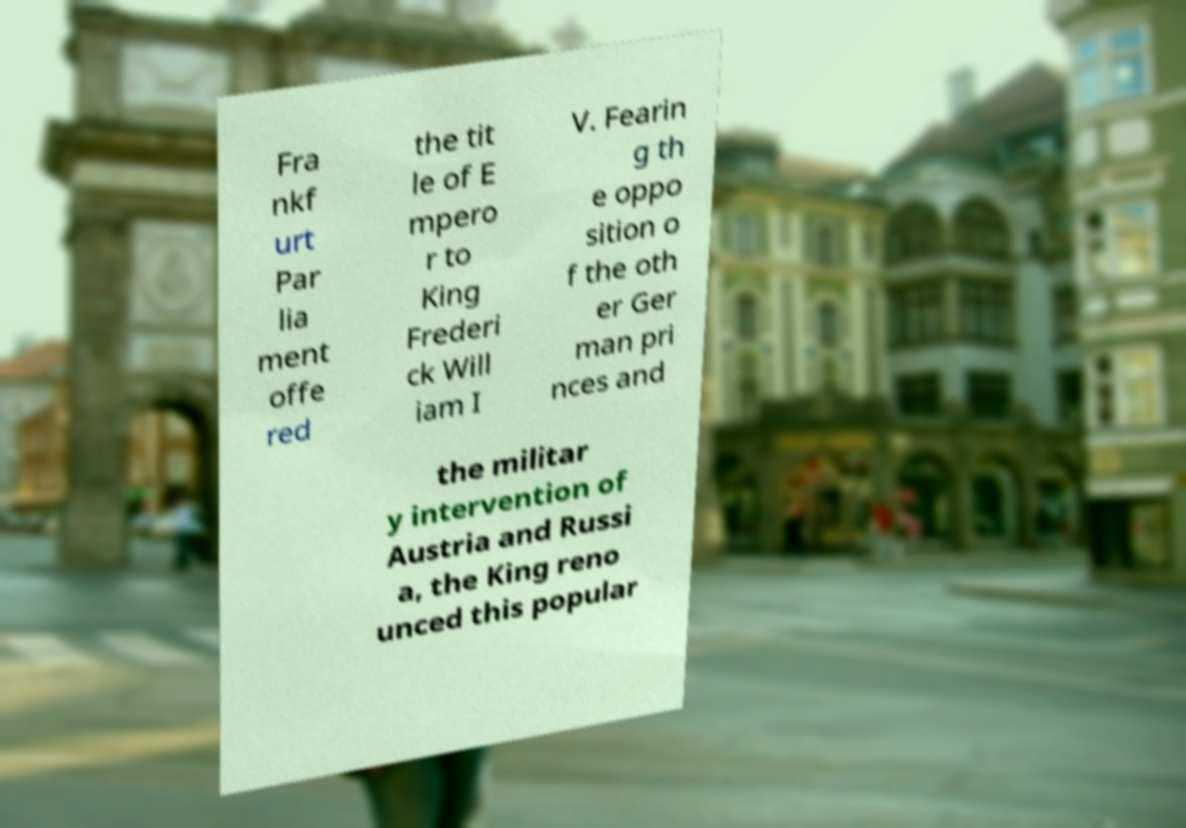I need the written content from this picture converted into text. Can you do that? Fra nkf urt Par lia ment offe red the tit le of E mpero r to King Frederi ck Will iam I V. Fearin g th e oppo sition o f the oth er Ger man pri nces and the militar y intervention of Austria and Russi a, the King reno unced this popular 